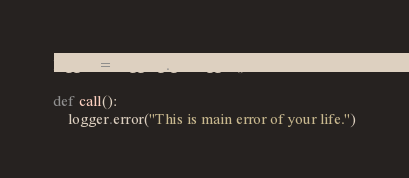Convert code to text. <code><loc_0><loc_0><loc_500><loc_500><_Python_>logger = logging.getLogger()

def call():
    logger.error("This is main error of your life.")</code> 